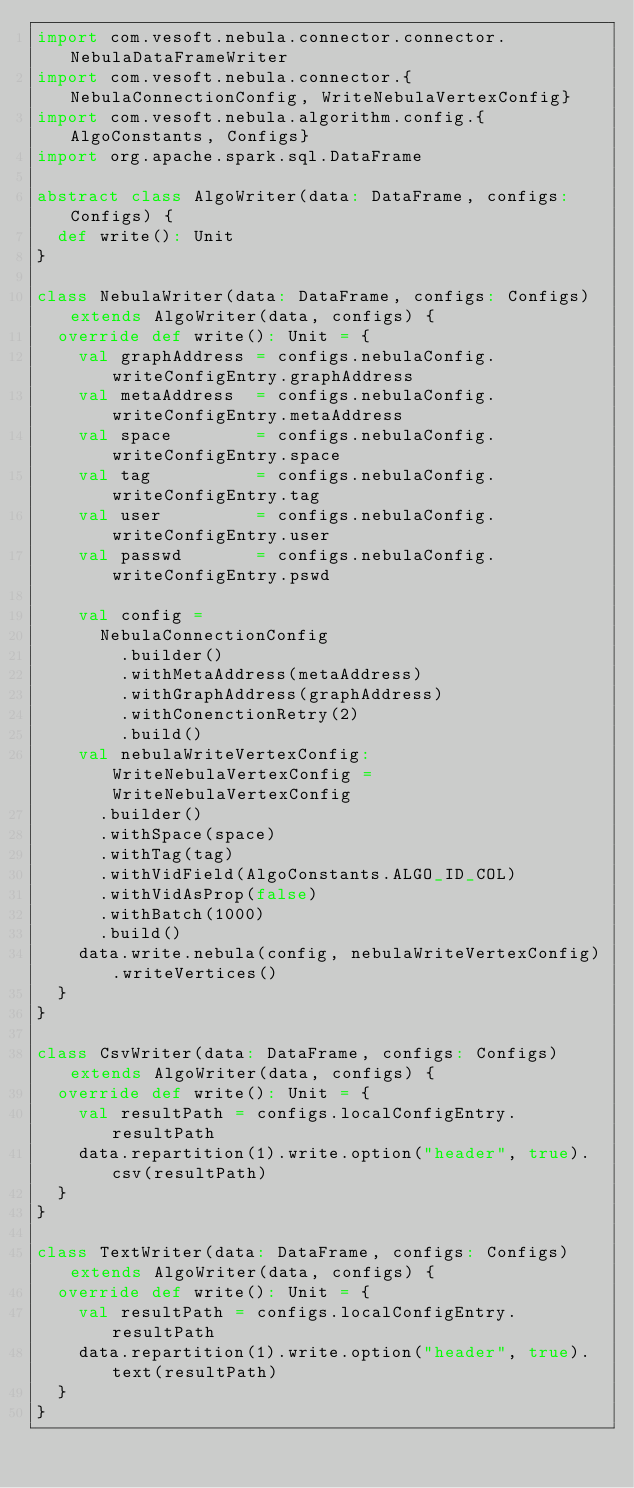<code> <loc_0><loc_0><loc_500><loc_500><_Scala_>import com.vesoft.nebula.connector.connector.NebulaDataFrameWriter
import com.vesoft.nebula.connector.{NebulaConnectionConfig, WriteNebulaVertexConfig}
import com.vesoft.nebula.algorithm.config.{AlgoConstants, Configs}
import org.apache.spark.sql.DataFrame

abstract class AlgoWriter(data: DataFrame, configs: Configs) {
  def write(): Unit
}

class NebulaWriter(data: DataFrame, configs: Configs) extends AlgoWriter(data, configs) {
  override def write(): Unit = {
    val graphAddress = configs.nebulaConfig.writeConfigEntry.graphAddress
    val metaAddress  = configs.nebulaConfig.writeConfigEntry.metaAddress
    val space        = configs.nebulaConfig.writeConfigEntry.space
    val tag          = configs.nebulaConfig.writeConfigEntry.tag
    val user         = configs.nebulaConfig.writeConfigEntry.user
    val passwd       = configs.nebulaConfig.writeConfigEntry.pswd

    val config =
      NebulaConnectionConfig
        .builder()
        .withMetaAddress(metaAddress)
        .withGraphAddress(graphAddress)
        .withConenctionRetry(2)
        .build()
    val nebulaWriteVertexConfig: WriteNebulaVertexConfig = WriteNebulaVertexConfig
      .builder()
      .withSpace(space)
      .withTag(tag)
      .withVidField(AlgoConstants.ALGO_ID_COL)
      .withVidAsProp(false)
      .withBatch(1000)
      .build()
    data.write.nebula(config, nebulaWriteVertexConfig).writeVertices()
  }
}

class CsvWriter(data: DataFrame, configs: Configs) extends AlgoWriter(data, configs) {
  override def write(): Unit = {
    val resultPath = configs.localConfigEntry.resultPath
    data.repartition(1).write.option("header", true).csv(resultPath)
  }
}

class TextWriter(data: DataFrame, configs: Configs) extends AlgoWriter(data, configs) {
  override def write(): Unit = {
    val resultPath = configs.localConfigEntry.resultPath
    data.repartition(1).write.option("header", true).text(resultPath)
  }
}
</code> 